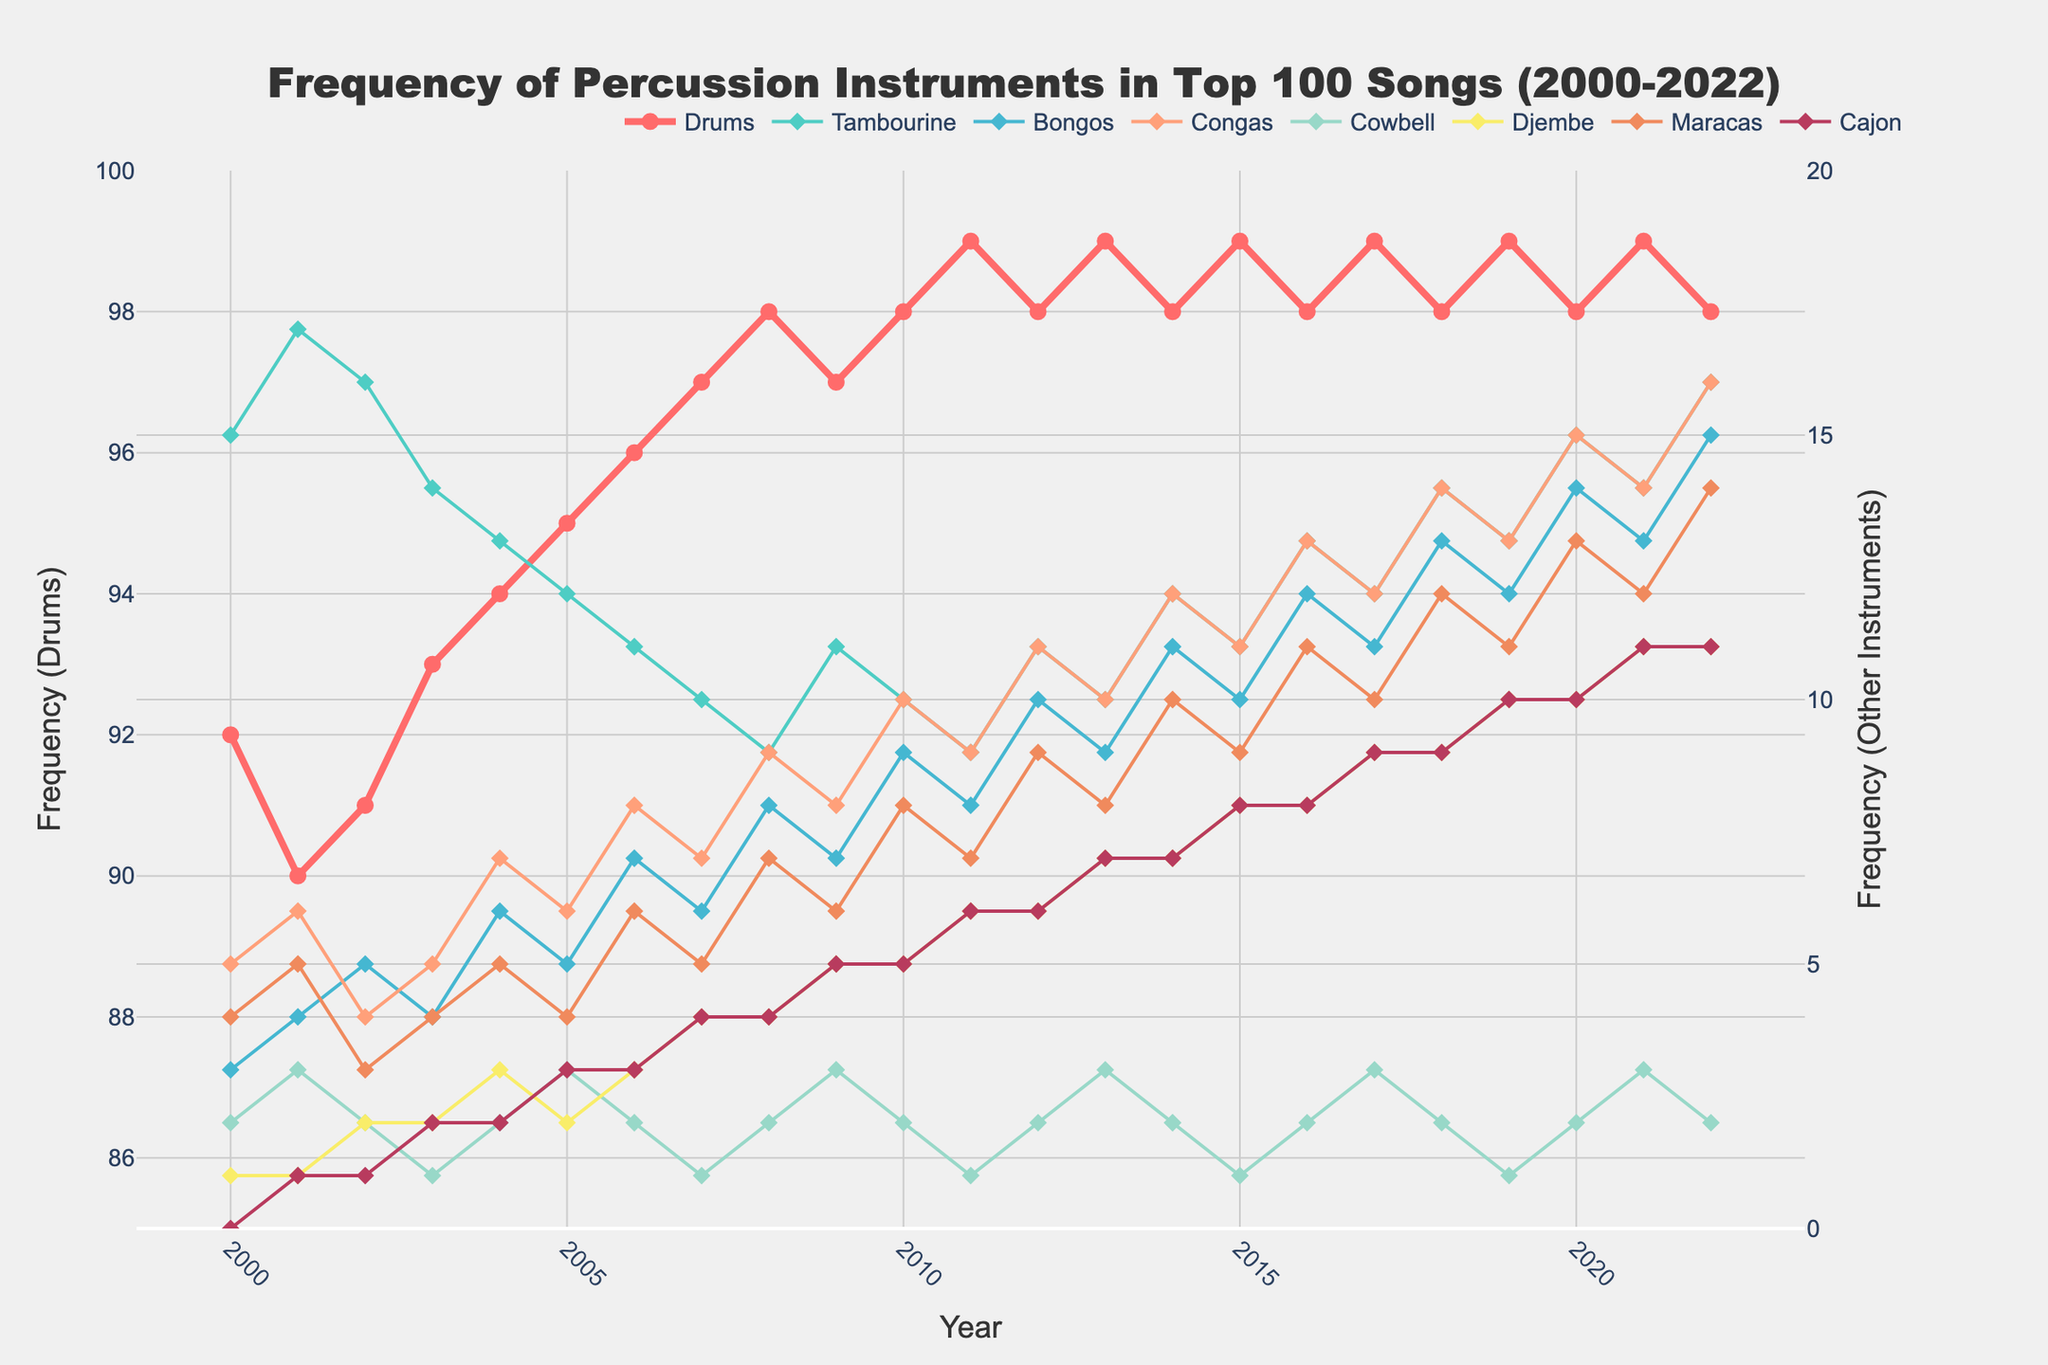What was the frequency of Drums usage in 2005? Find the point on the Drums line chart corresponding to 2005, and read the value on the primary y-axis.
Answer: 95 Which year saw the highest usage of Tambourine? Identify the peak point on the Tambourine line (light blue) and check the corresponding year on the x-axis.
Answer: 2020 Which instrument showed a steady increase in usage from 2000 to 2022? Look for a line that consistently trends upward from 2000 to 2022. The Djembe (navy blue) line shows a steady increase.
Answer: Djembe Compare the frequency of Congas usage in 2008 and 2022. What is the difference? Find the Congas values for 2008 (9) and 2022 (16) by checking points on the Congas line and calculate the difference (16 - 9).
Answer: 7 How does the frequency of Bongos in 2010 compare to 2020? Locate the Bongos values for 2010 (9) and 2020 (14) using the secondary y-axis, then determine the difference.
Answer: 5 Between which consecutive years did Cajon usage increase the most? Identify the largest upward jump by finding the steepest segment in the Cajon (purple) line. Cajon usage from 2009 (5) to 2010 (8) has the largest increase (3).
Answer: 2009 to 2010 What is the minimum frequency for Cowbell over the years? Find the lowest point on the Cowbell line (orange) which is in 2003 with a value of 1.
Answer: 1 How many years did Maracas usage surpass 10? Count the points on the Maracas line (orange-brown) above 10 on the secondary y-axis, which are 5 years (2015, 2016, 2018, 2020, 2021, 2022).
Answer: 6 years What is the trend in Drums usage over the time period? Examine the Drums line (thicker red line) from 2000 to 2022, which shows a generally high and stable trend.
Answer: High and stable Which instrument had the sharpest increase in frequency in a single year? Look for the steepest slope in any line; Maracas showed a sharp increase from 2021 (12) to 2022 (14).
Answer: Maracas from 2021 to 2022 